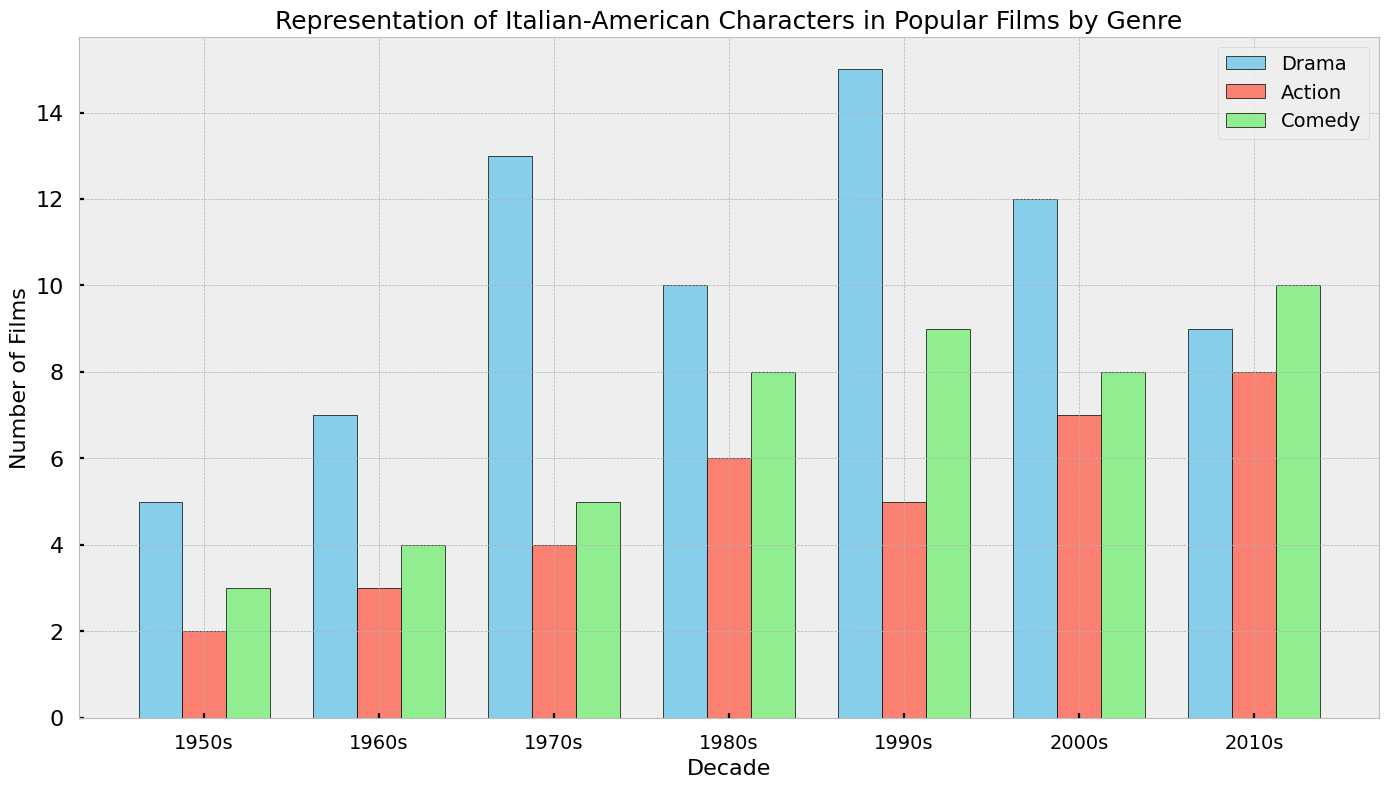What genre had the highest number of films featuring Italian-American characters in the 1990s? Look at the 1990s on the x-axis and compare the heights of the bars for Drama, Action, and Comedy. The Drama bar is the tallest.
Answer: Drama Which decade had the most Italian-American characters featured in Comedy films? Compare the heights of the green bars across all decades. The tallest green bar is in the 2010s.
Answer: 2010s What was the total number of films featuring Italian-American characters across all genres in the 1950s? Sum the heights of all bars (Drama, Action, Comedy) for the 1950s. 5 + 2 + 3 = 10.
Answer: 10 Between the 1970s and 1980s, which decade saw a higher total number of films featuring Italian-American characters in Action films? Compare the heights of the red bars between the 1970s and 1980s. The 1980s bar is taller with 6 films, compared to 4 in the 1970s.
Answer: 1980s What is the difference in the number of Italian-American Comedy films between the 1960s and 2010s? Subtract the number of Comedy films in the 1960s from the number in the 2010s. 10 - 4 = 6.
Answer: 6 In which decade did Drama films featuring Italian-American characters decline the most compared to the previous decade? Compare the height differences of blue bars for consecutive decades. The biggest drop is from the 1990s (15) to the 2010s (9), a decline of 6 films.
Answer: 2010s How many more Drama films than Action films featuring Italian-American characters were made in the 2000s? Subtract the number of Action films from Drama films in the 2000s. 12 - 7 = 5.
Answer: 5 Which genre was least represented in films featuring Italian-American characters during the 1960s? Look at the 1960s and compare the heights of the bars for Drama, Action, and Comedy. The shortest is Action with 3 films.
Answer: Action Were there more Comedy or Drama films featuring Italian-American characters in the 1980s? Compare the height of the green (Comedy) bar to the blue (Drama) bar in the 1980s. Drama has 10, Comedy has 8, so there were more Drama films.
Answer: Drama How many more total films featuring Italian-American characters were there in the 2000s compared to the 1950s? First, find the total for each decade by summing the bar heights. 1950s: 5 + 2 + 3 = 10, 2000s: 12 + 7 + 8 = 27. Subtract the total of the 1950s from the total of the 2000s. 27 - 10 = 17.
Answer: 17 